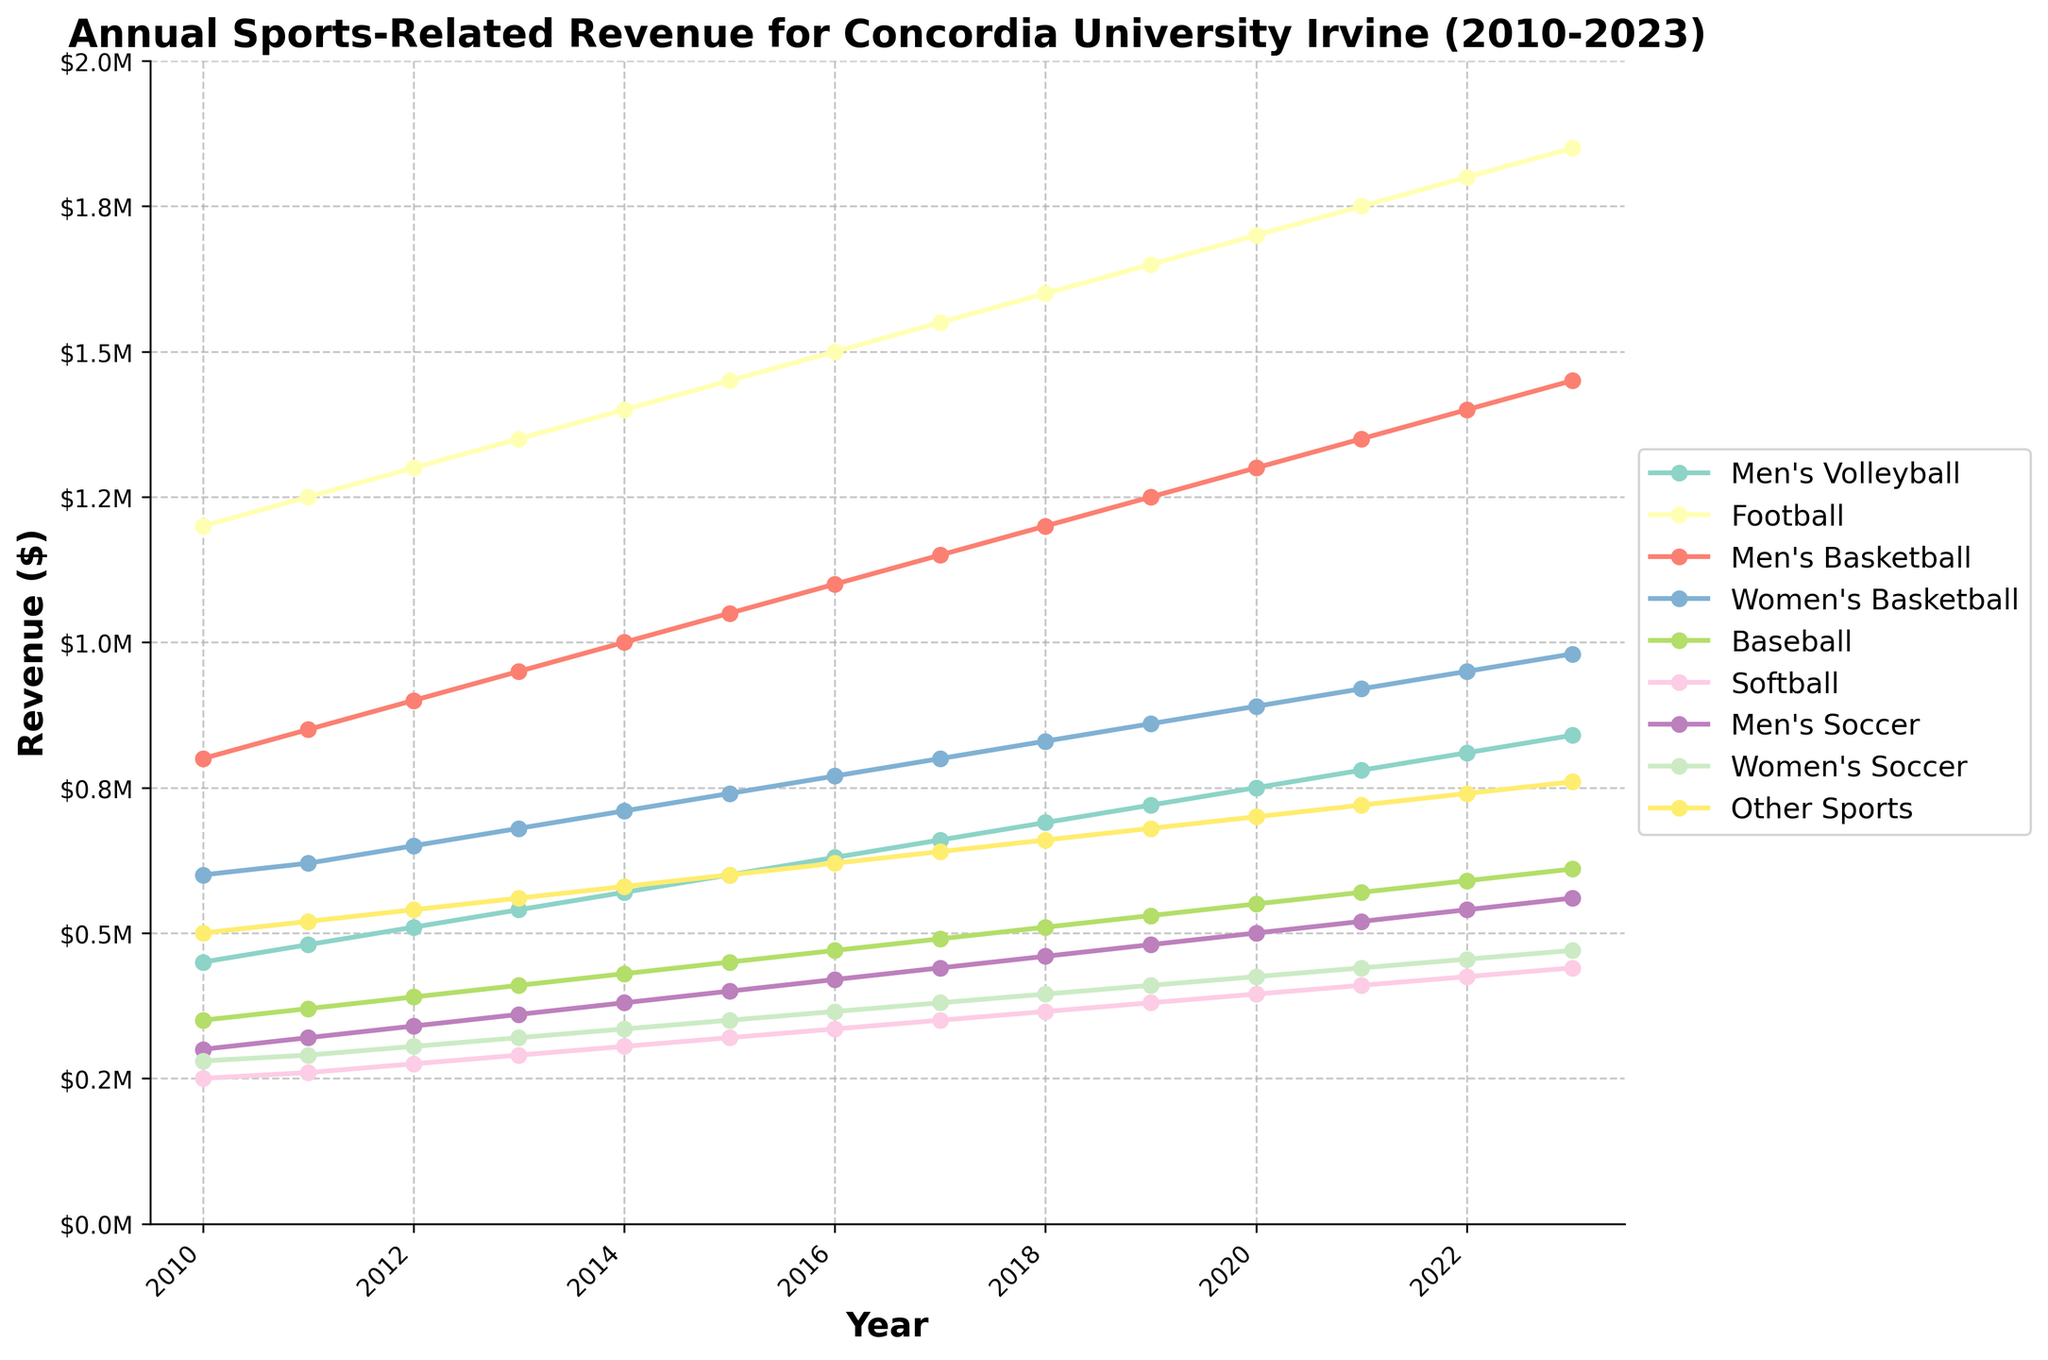What's the overall trend in the revenue for Men's Volleyball from 2010 to 2023? By observing the line for Men's Volleyball, it starts at $450,000 in 2010 and steadily increases each year, reaching $840,000 in 2023.
Answer: Increasing trend Which sport had the highest revenue in 2023? Identify the line that reaches the highest point in 2023. The line for Football reaches $1,850,000, which is the highest among all sports.
Answer: Football How does the revenue growth for Women's Basketball compare to Men's Basketball from 2010 to 2023? Both lines start growing from 2010 to 2023. Women's Basketball starts at $600,000 and reaches $980,000, while Men's Basketball starts at $800,000 and reaches $1,450,000. Men's Basketball had higher starting and ending revenue, indicating greater growth.
Answer: Men's Basketball had greater growth What was the total revenue for all sports in 2020? Add the revenues for all sports for the year 2020:
$750,000 (Men's Volleyball) + $1,700,000 (Football) + $1,300,000 (Men's Basketball) + $890,000 (Women's Basketball) + $550,000 (Baseball) + $395,000 (Softball) + $500,000 (Men's Soccer) + $425,000 (Women's Soccer) + $700,000 (Other Sports) = $7,210,000
Answer: $7,210,000 Which sport had the least revenue in 2015? Identify the line that reaches the lowest point in 2015. The line for Softball is the lowest, at $320,000.
Answer: Softball What is the average revenue for Women's Soccer between 2010 and 2023? Calculate the average by adding the yearly revenues for Women's Soccer and dividing by the number of years: 
($280,000 + $290,000 + $305,000 + $320,000 + $335,000 + $350,000 + $365,000 + $380,000 + $395,000 + $410,000 + $425,000 + $440,000 + $455,000 + $470,000) / 14 = $364,285.71
Answer: $364,285.71 Which sports had more revenue than Baseball in 2013? Compare each sport's revenue with Baseball's revenue in 2013 ($410,000). The sports with higher revenue are Men's Volleyball ($540,000), Football ($1,350,000), Men's Basketball ($950,000), and Women's Basketball ($680,000).
Answer: Men's Volleyball, Football, Men's Basketball, Women's Basketball What was the percentage increase in revenue for Football from 2010 to 2023? Calculate the percentage increase:
((2023 revenue - 2010 revenue) / 2010 revenue) * 100
((1,850,000 - 1,200,000) / 1,200,000) * 100 = 54.17%
Answer: 54.17% Which sport showed the most consistent revenue growth over the years? Observe the lines and note which line shows steady and consistent growth without abrupt changes. Football displays a consistent and steady upward trend.
Answer: Football 